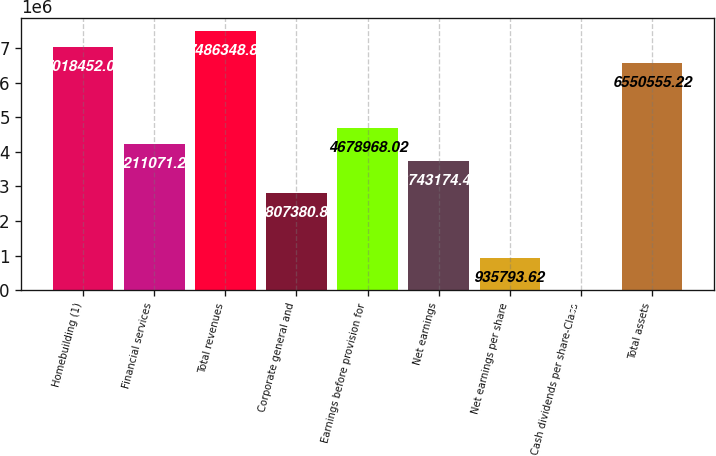Convert chart. <chart><loc_0><loc_0><loc_500><loc_500><bar_chart><fcel>Homebuilding (1)<fcel>Financial services<fcel>Total revenues<fcel>Corporate general and<fcel>Earnings before provision for<fcel>Net earnings<fcel>Net earnings per share<fcel>Cash dividends per share-Class<fcel>Total assets<nl><fcel>7.01845e+06<fcel>4.21107e+06<fcel>7.48635e+06<fcel>2.80738e+06<fcel>4.67897e+06<fcel>3.74317e+06<fcel>935794<fcel>0.02<fcel>6.55056e+06<nl></chart> 